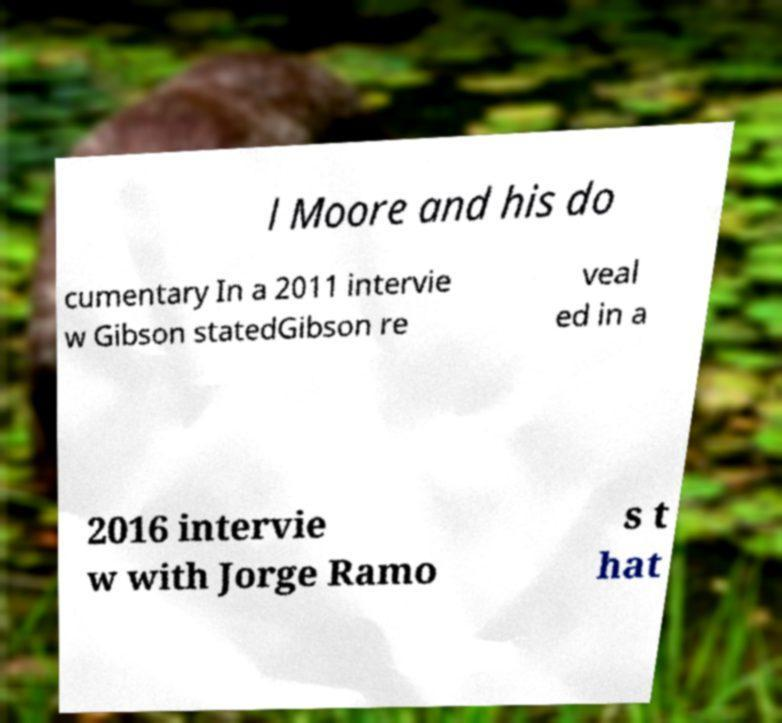For documentation purposes, I need the text within this image transcribed. Could you provide that? l Moore and his do cumentary In a 2011 intervie w Gibson statedGibson re veal ed in a 2016 intervie w with Jorge Ramo s t hat 